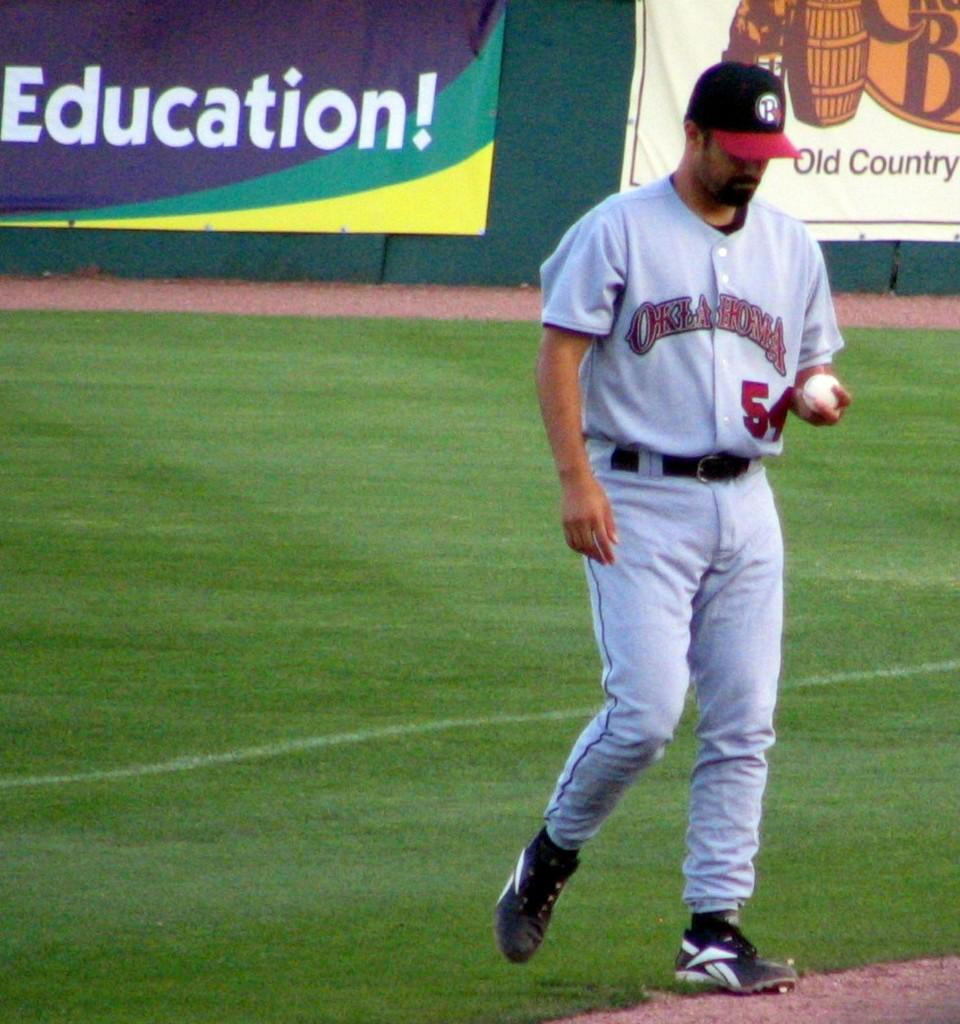<image>
Summarize the visual content of the image. A sportsman with the word Education on a banner behind him, 